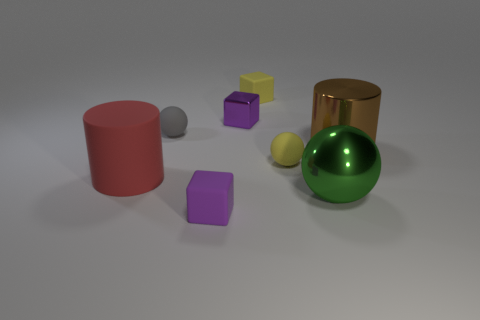Can you describe the different shapes and colors visible in the image? Certainly! The image depicts a variety of geometric shapes with different colors. We have a red cylinder, a green big shiny sphere, a gray small matte sphere, a gold shiny cylinder, a violet matte cube, a small yellow matte cube, and a small purple cube. The background is neutral with soft shadows cast by the objects. 